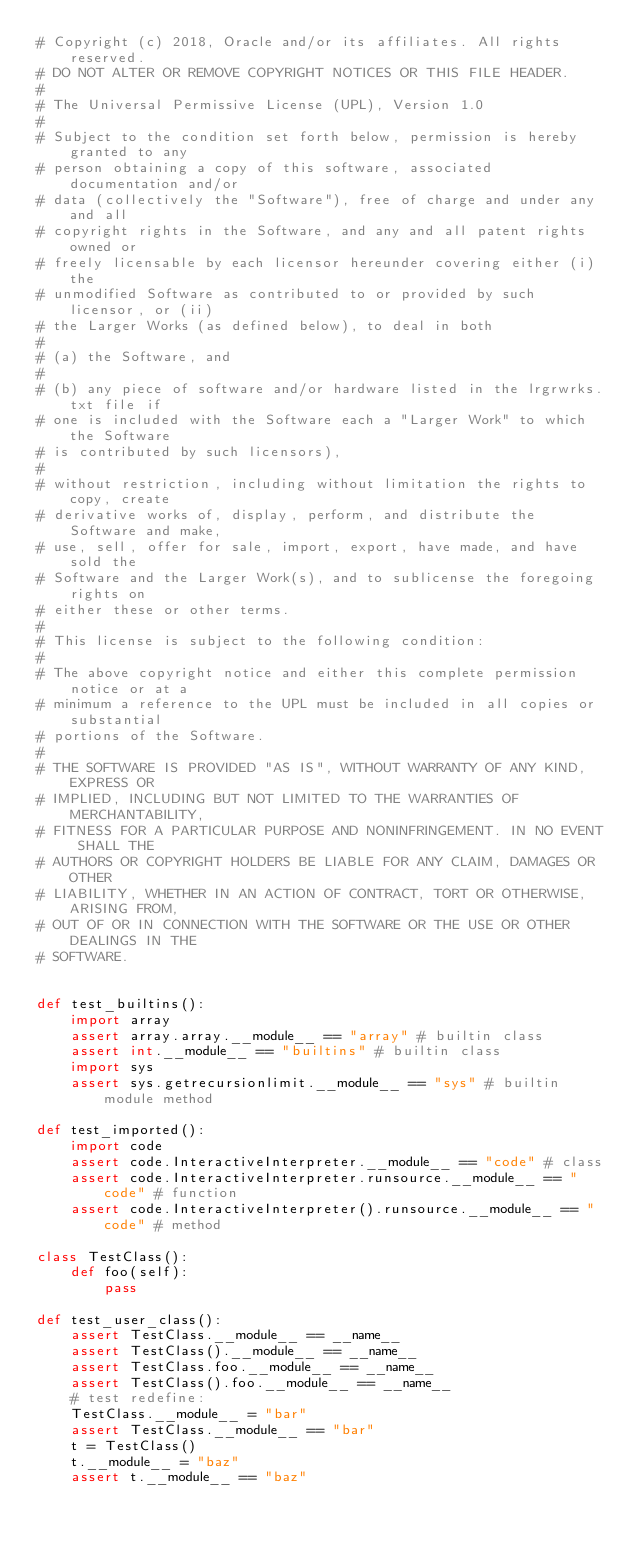<code> <loc_0><loc_0><loc_500><loc_500><_Python_># Copyright (c) 2018, Oracle and/or its affiliates. All rights reserved.
# DO NOT ALTER OR REMOVE COPYRIGHT NOTICES OR THIS FILE HEADER.
#
# The Universal Permissive License (UPL), Version 1.0
#
# Subject to the condition set forth below, permission is hereby granted to any
# person obtaining a copy of this software, associated documentation and/or
# data (collectively the "Software"), free of charge and under any and all
# copyright rights in the Software, and any and all patent rights owned or
# freely licensable by each licensor hereunder covering either (i) the
# unmodified Software as contributed to or provided by such licensor, or (ii)
# the Larger Works (as defined below), to deal in both
#
# (a) the Software, and
#
# (b) any piece of software and/or hardware listed in the lrgrwrks.txt file if
# one is included with the Software each a "Larger Work" to which the Software
# is contributed by such licensors),
#
# without restriction, including without limitation the rights to copy, create
# derivative works of, display, perform, and distribute the Software and make,
# use, sell, offer for sale, import, export, have made, and have sold the
# Software and the Larger Work(s), and to sublicense the foregoing rights on
# either these or other terms.
#
# This license is subject to the following condition:
#
# The above copyright notice and either this complete permission notice or at a
# minimum a reference to the UPL must be included in all copies or substantial
# portions of the Software.
#
# THE SOFTWARE IS PROVIDED "AS IS", WITHOUT WARRANTY OF ANY KIND, EXPRESS OR
# IMPLIED, INCLUDING BUT NOT LIMITED TO THE WARRANTIES OF MERCHANTABILITY,
# FITNESS FOR A PARTICULAR PURPOSE AND NONINFRINGEMENT. IN NO EVENT SHALL THE
# AUTHORS OR COPYRIGHT HOLDERS BE LIABLE FOR ANY CLAIM, DAMAGES OR OTHER
# LIABILITY, WHETHER IN AN ACTION OF CONTRACT, TORT OR OTHERWISE, ARISING FROM,
# OUT OF OR IN CONNECTION WITH THE SOFTWARE OR THE USE OR OTHER DEALINGS IN THE
# SOFTWARE.


def test_builtins():
    import array
    assert array.array.__module__ == "array" # builtin class
    assert int.__module__ == "builtins" # builtin class
    import sys
    assert sys.getrecursionlimit.__module__ == "sys" # builtin module method

def test_imported():
    import code
    assert code.InteractiveInterpreter.__module__ == "code" # class
    assert code.InteractiveInterpreter.runsource.__module__ == "code" # function
    assert code.InteractiveInterpreter().runsource.__module__ == "code" # method

class TestClass():
    def foo(self):
        pass

def test_user_class():
    assert TestClass.__module__ == __name__
    assert TestClass().__module__ == __name__
    assert TestClass.foo.__module__ == __name__
    assert TestClass().foo.__module__ == __name__
    # test redefine:
    TestClass.__module__ = "bar"
    assert TestClass.__module__ == "bar"
    t = TestClass()
    t.__module__ = "baz"
    assert t.__module__ == "baz"
</code> 